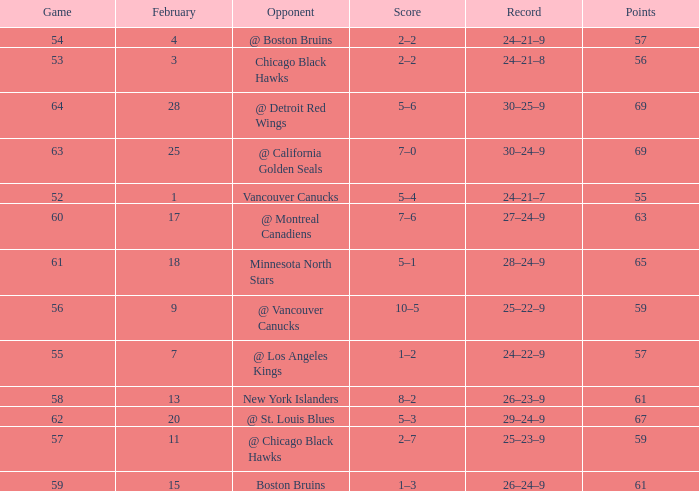Which opponent has a game larger than 61, february smaller than 28, and fewer points than 69? @ St. Louis Blues. 